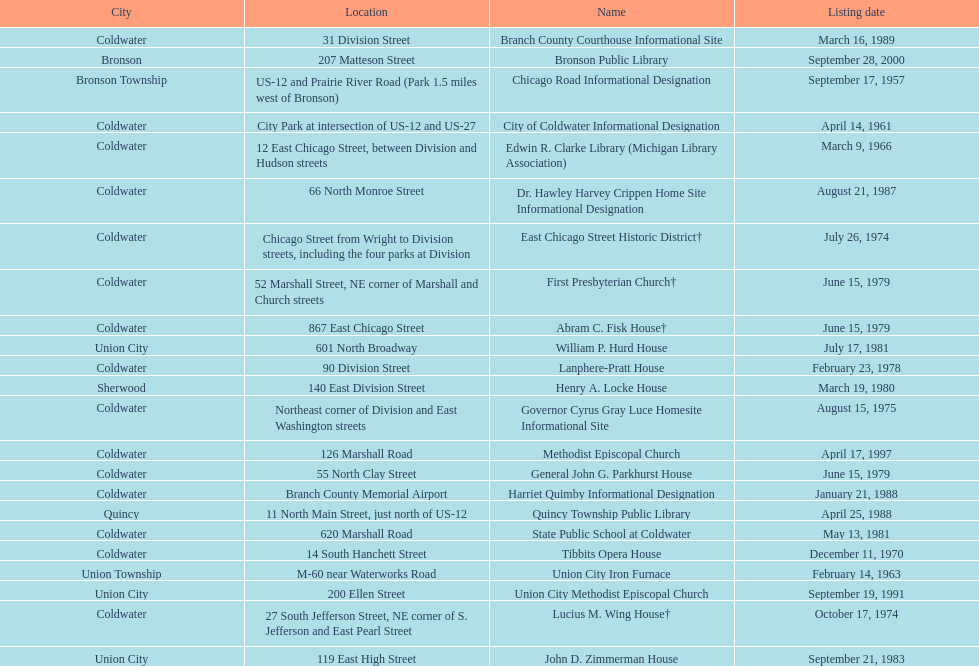How many sites are in coldwater? 15. 